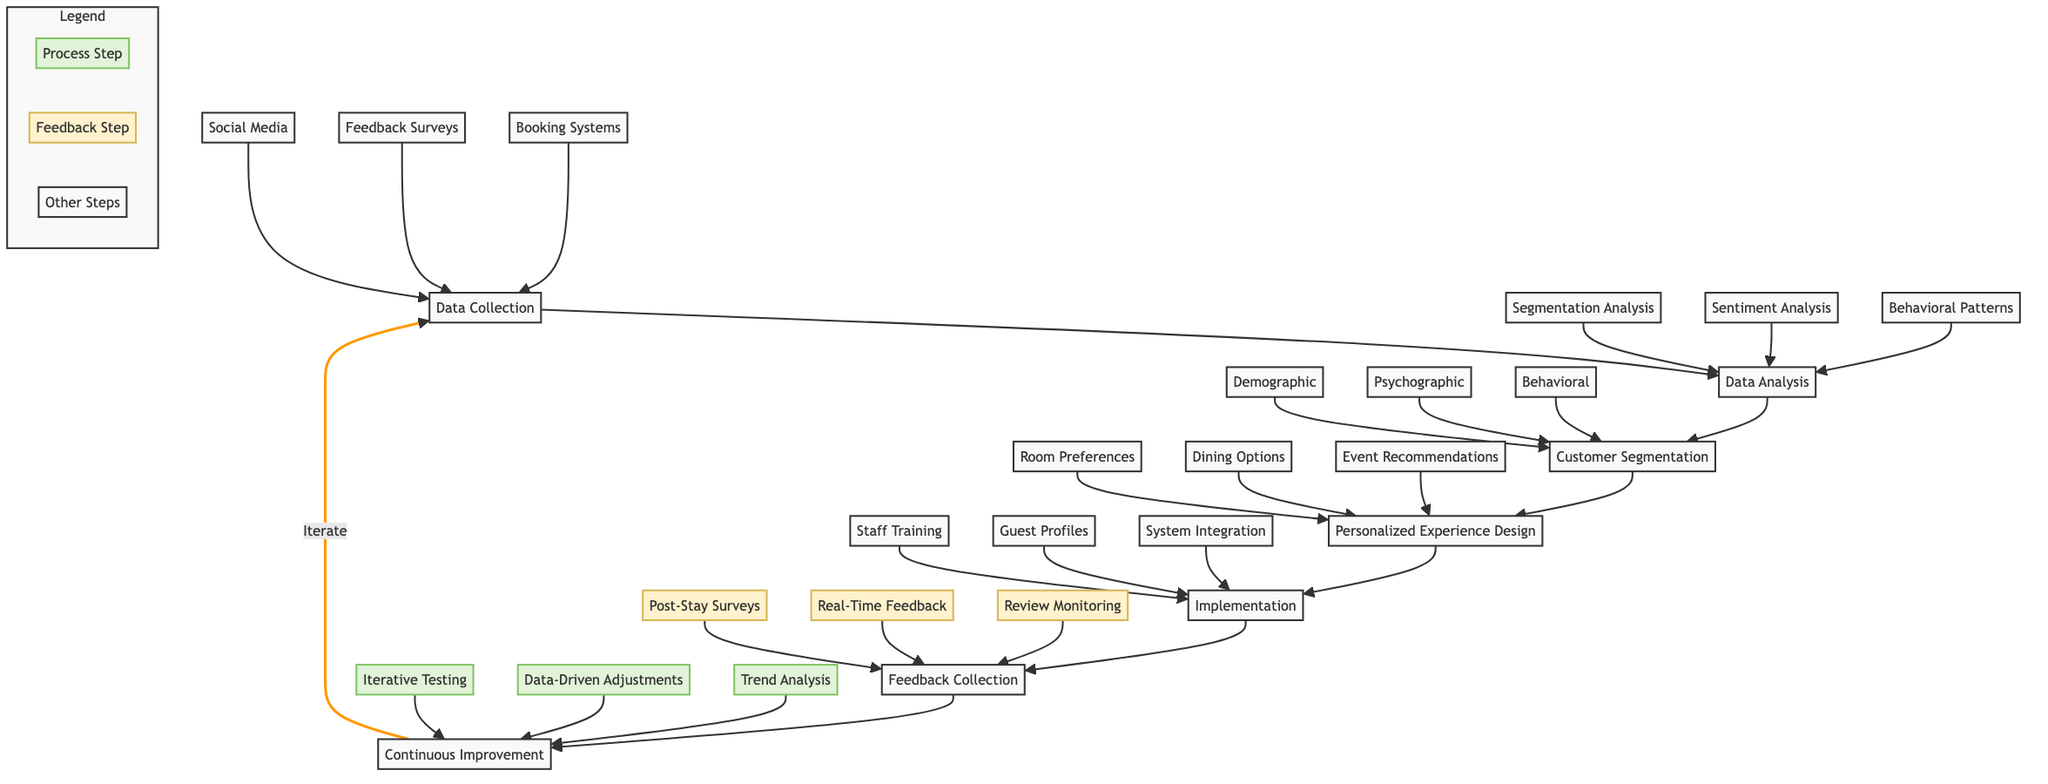What is the first step in the workflow? The first step in the workflow is indicated by the starting node, which is "Data Collection."
Answer: Data Collection How many steps are in the main workflow? To determine the number of steps, we can count the main nodes connected in sequence: Data Collection, Data Analysis, Customer Segmentation, Personalized Experience Design, Implementation, Feedback Collection, and Continuous Improvement. This gives us a total of 7 steps.
Answer: 7 Which data source relates to "Customer Segmentation"? The only data source that directly relates to "Customer Segmentation" is the node "Data Analysis," which is the preceding step before this segmentation takes place.
Answer: Data Analysis What are the three types of analysis in the "Data Analysis" step? Referring to the sub-elements of the "Data Analysis" step, the three types of analysis are Segmentation Analysis, Sentiment Analysis, and Behavioral Pattern Identification.
Answer: Segmentation Analysis, Sentiment Analysis, Behavioral Pattern Identification What action occurs after "Feedback Collection"? The action that occurs after "Feedback Collection" is represented by the node "Continuous Improvement," indicating that feedback is used to enhance the experiences further.
Answer: Continuous Improvement How many sub-elements are there in the "Implementation" step? By examining the sub-elements listed under the "Implementation" node, we find three sub-elements: Staff Training, Updating Guest Profiles, and Integrating Systems. Therefore, there are three sub-elements.
Answer: 3 What is the relationship between "Continuous Improvement" and "Data Collection"? The relationship is cyclical; the flow indicates that Continuous Improvement leads back to Data Collection, suggesting an iterative process where improved experiences generate new data to be collected again.
Answer: Iterate What are the feedback sources for the "Feedback Collection" step? The three feedback sources for the "Feedback Collection" step include Post-Stay Surveys, Real-Time Feedback, and Review Monitoring, which are all sub-elements of this step.
Answer: Post-Stay Surveys, Real-Time Feedback, Review Monitoring What are the three types of segmentation mentioned? The three types of segmentation mentioned are Demographic Segmentation, Psychographic Segmentation, and Behavioral Segmentation, which are all listed as sub-elements under "Customer Segmentation."
Answer: Demographic Segmentation, Psychographic Segmentation, Behavioral Segmentation 